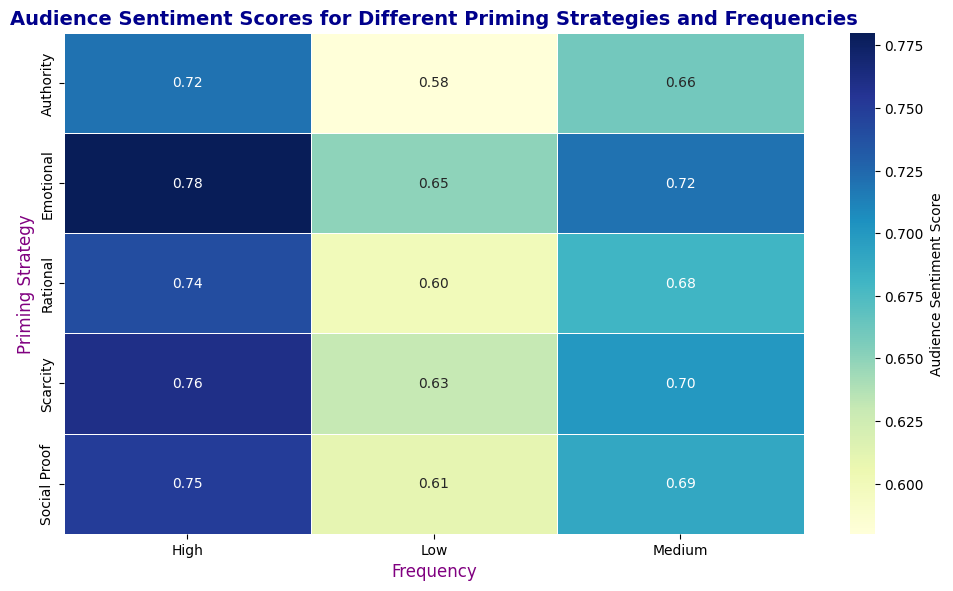What is the highest Audience Sentiment Score for the Emotional priming strategy? The heatmap shows the Audience Sentiment Scores for various priming strategies across different frequencies. For the Emotional priming strategy, we look at the scores for Low, Medium, and High frequencies. The scores are 0.65, 0.72, and 0.78, respectively. The highest among these is 0.78 for High frequency.
Answer: 0.78 Which priming strategy has the lowest Audience Sentiment Score at Low frequency? To find this, we look at the heatmap at the Low frequency column and compare the scores for all priming strategies. The scores are: Emotional (0.65), Rational (0.60), Scarcity (0.63), Authority (0.58), and Social Proof (0.61). The lowest score is 0.58 for Authority.
Answer: Authority How much higher is the Audience Sentiment Score for Emotional at High frequency compared to Rational at Low frequency? First, find the Audience Sentiment Score for Emotional at High frequency (0.78) and for Rational at Low frequency (0.60). The difference is calculated as 0.78 - 0.60 = 0.18.
Answer: 0.18 What is the average Audience Sentiment Score for the Social Proof priming strategy across all frequencies? We find the scores for Social Proof: Low (0.61), Medium (0.69), and High (0.75). Sum these values (0.61 + 0.69 + 0.75 = 2.05) and then divide by the number of categories (3): 2.05 / 3 ≈ 0.6833.
Answer: 0.68 Which frequency has the most consistent Audience Sentiment Scores across different priming strategies? We compare the variability of scores across priming strategies at each frequency (Low, Medium, and High). At Low frequency, scores vary between 0.58 to 0.65; at Medium frequency, scores vary between 0.66 to 0.72; and at High frequency, scores vary between 0.72 to 0.78. The range is smallest at Medium frequency (0.66 to 0.72), indicating more consistency.
Answer: Medium What is the overall trend in Audience Sentiment Scores as the frequency increases for all priming strategies? By examining the heatmap, we observe that for each priming strategy, the Audience Sentiment Score increases from Low to Medium to High frequency. This suggests a positive trend in sentiment as frequency increases.
Answer: Positive trend Between Scarcity and Authority priming strategies at High frequency, which one has a higher Audience Sentiment Score? We compare the Scores for Scarcity and Authority at High frequency. Scarcity has a score of 0.76, while Authority has a score of 0.72. Therefore, Scarcity has a higher score.
Answer: Scarcity 